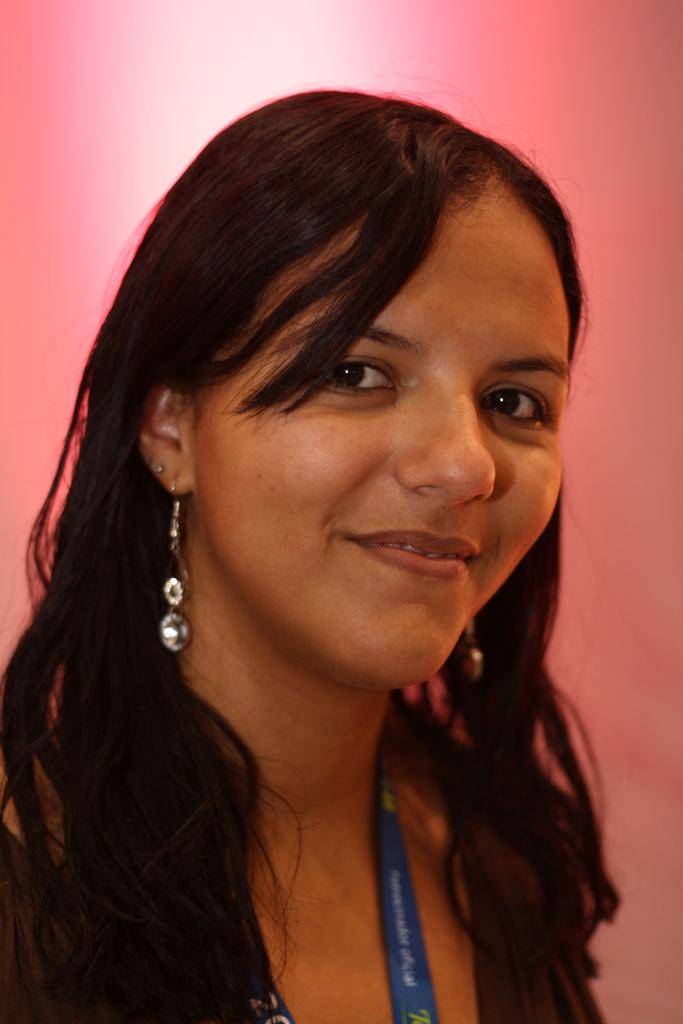What is the main subject of the image? The main subject of the image is a woman's face. What expression does the woman have in the image? The woman is smiling in the image. What type of toothpaste is the woman using in the image? There is no toothpaste present in the image, as it only features a woman's face. How does the woman's face appear to be interacting with the water in the image? There is no water present in the image, as it only features a woman's face. 